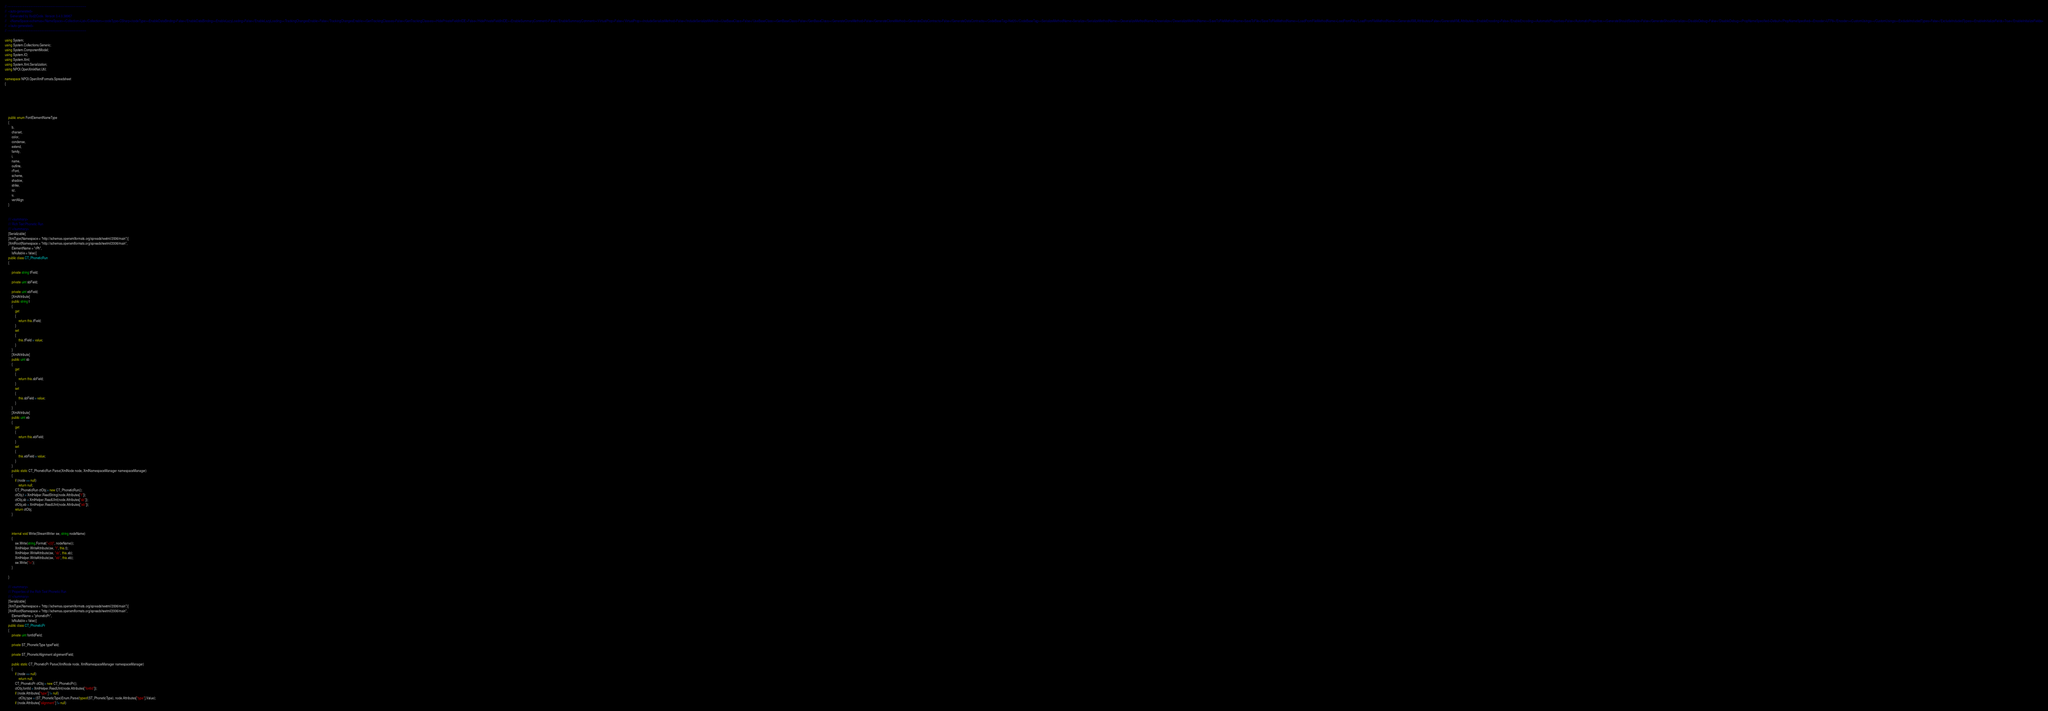Convert code to text. <code><loc_0><loc_0><loc_500><loc_500><_C#_>// ------------------------------------------------------------------------------
//  <auto-generated>
//    Generated by Xsd2Code. Version 3.4.0.38967
//    <NameSpace>schemas</NameSpace><Collection>List</Collection><codeType>CSharp</codeType><EnableDataBinding>False</EnableDataBinding><EnableLazyLoading>False</EnableLazyLoading><TrackingChangesEnable>False</TrackingChangesEnable><GenTrackingClasses>False</GenTrackingClasses><HidePrivateFieldInIDE>False</HidePrivateFieldInIDE><EnableSummaryComment>False</EnableSummaryComment><VirtualProp>False</VirtualProp><IncludeSerializeMethod>False</IncludeSerializeMethod><UseBaseClass>False</UseBaseClass><GenBaseClass>False</GenBaseClass><GenerateCloneMethod>False</GenerateCloneMethod><GenerateDataContracts>False</GenerateDataContracts><CodeBaseTag>Net20</CodeBaseTag><SerializeMethodName>Serialize</SerializeMethodName><DeserializeMethodName>Deserialize</DeserializeMethodName><SaveToFileMethodName>SaveToFile</SaveToFileMethodName><LoadFromFileMethodName>LoadFromFile</LoadFromFileMethodName><GenerateXMLAttributes>False</GenerateXMLAttributes><EnableEncoding>False</EnableEncoding><AutomaticProperties>False</AutomaticProperties><GenerateShouldSerialize>False</GenerateShouldSerialize><DisableDebug>False</DisableDebug><PropNameSpecified>Default</PropNameSpecified><Encoder>UTF8</Encoder><CustomUsings></CustomUsings><ExcludeIncludedTypes>False</ExcludeIncludedTypes><EnableInitializeFields>True</EnableInitializeFields>
//  </auto-generated>
// ------------------------------------------------------------------------------

using System;
using System.Collections.Generic;
using System.ComponentModel;
using System.IO;
using System.Xml;
using System.Xml.Serialization;
using NPOI.OpenXml4Net.Util;

namespace NPOI.OpenXmlFormats.Spreadsheet
{






    public enum FontElementNameType
    {
        b,
        charset,
        color,
        condense,
        extend,
        family,
        i,
        name,
        outline,
        rFont,
        scheme,
        shadow,
        strike,
        sz,
        u,
        vertAlign
    }


    /// <summary>
    /// Rich Text Phonetic Run
    /// </summary>
    [Serializable]
    [XmlType(Namespace = "http://schemas.openxmlformats.org/spreadsheetml/2006/main")]
    [XmlRoot(Namespace = "http://schemas.openxmlformats.org/spreadsheetml/2006/main",
        ElementName = "rPh",
        IsNullable = false)]
    public class CT_PhoneticRun
    {

        private string tField;

        private uint sbField;

        private uint ebField;
        [XmlAttribute]
        public string t
        {
            get
            {
                return this.tField;
            }
            set
            {
                this.tField = value;
            }
        }
        [XmlAttribute]
        public uint sb
        {
            get
            {
                return this.sbField;
            }
            set
            {
                this.sbField = value;
            }
        }
        [XmlAttribute]
        public uint eb
        {
            get
            {
                return this.ebField;
            }
            set
            {
                this.ebField = value;
            }
        }
        public static CT_PhoneticRun Parse(XmlNode node, XmlNamespaceManager namespaceManager)
        {
            if (node == null)
                return null;
            CT_PhoneticRun ctObj = new CT_PhoneticRun();
            ctObj.t = XmlHelper.ReadString(node.Attributes["t"]);
            ctObj.sb = XmlHelper.ReadUInt(node.Attributes["sb"]);
            ctObj.eb = XmlHelper.ReadUInt(node.Attributes["eb"]);
            return ctObj;
        }



        internal void Write(StreamWriter sw, string nodeName)
        {
            sw.Write(string.Format("<{0}", nodeName));
            XmlHelper.WriteAttribute(sw, "t", this.t);
            XmlHelper.WriteAttribute(sw, "sb", this.sb);
            XmlHelper.WriteAttribute(sw, "eb", this.eb);
            sw.Write("/>");
        }

    }

    /// <summary>
    /// Properties of the Rich Text Phonetic Run
    /// </summary>
    [Serializable]
    [XmlType(Namespace = "http://schemas.openxmlformats.org/spreadsheetml/2006/main")]
    [XmlRoot(Namespace = "http://schemas.openxmlformats.org/spreadsheetml/2006/main",
        ElementName = "phoneticPr",
        IsNullable = false)]
    public class CT_PhoneticPr
    {
        private uint fontIdField;

        private ST_PhoneticType typeField;

        private ST_PhoneticAlignment alignmentField;

        public static CT_PhoneticPr Parse(XmlNode node, XmlNamespaceManager namespaceManager)
        {
            if (node == null)
                return null;
            CT_PhoneticPr ctObj = new CT_PhoneticPr();
            ctObj.fontId = XmlHelper.ReadUInt(node.Attributes["fontId"]);
            if (node.Attributes["type"] != null)
                ctObj.type = (ST_PhoneticType)Enum.Parse(typeof(ST_PhoneticType), node.Attributes["type"].Value);
            if (node.Attributes["alignment"] != null)</code> 